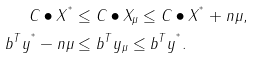<formula> <loc_0><loc_0><loc_500><loc_500>C \bullet X ^ { ^ { * } } & \leq C \bullet X _ { \mu } \leq C \bullet X ^ { ^ { * } } + n \mu , \\ b ^ { T } y ^ { ^ { * } } - n \mu & \leq b ^ { T } y _ { \mu } \leq b ^ { T } y ^ { ^ { * } } .</formula> 